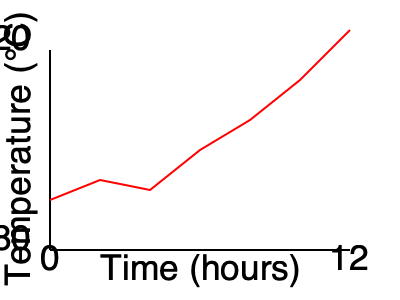Based on the engine temperature graph shown, at what point (in hours) should you schedule maintenance to prevent potential overheating issues? To determine when maintenance should be scheduled, follow these steps:

1. Analyze the graph: The x-axis represents time in hours, and the y-axis represents temperature in °C.

2. Identify the trend: The graph shows an overall increasing trend in engine temperature over time.

3. Locate critical points: Look for areas where the temperature rise is more rapid or approaches a concerning level.

4. Determine the safe operating range: For most truck engines, the safe operating temperature is typically between 82°C and 99°C (180°F to 210°F).

5. Identify the danger zone: Temperatures above 105°C (220°F) can indicate potential overheating issues.

6. Pinpoint the critical time: In this graph, the temperature appears to reach around 105°C at approximately the 9-hour mark.

7. Apply a safety margin: To prevent potential overheating, it's wise to schedule maintenance before reaching the critical point. A good rule of thumb is to plan for maintenance about 2 hours before the expected critical point.

8. Calculate the maintenance time: 9 hours (critical point) - 2 hours (safety margin) = 7 hours

Therefore, based on this analysis, maintenance should be scheduled at around the 7-hour mark to prevent potential overheating issues.
Answer: 7 hours 